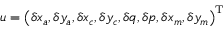<formula> <loc_0><loc_0><loc_500><loc_500>u = \left ( \delta x _ { a } , \delta y _ { a } , \delta x _ { c } , \delta y _ { c } , \delta q , \delta p , \delta x _ { m } , \delta y _ { m } \right ) ^ { T }</formula> 